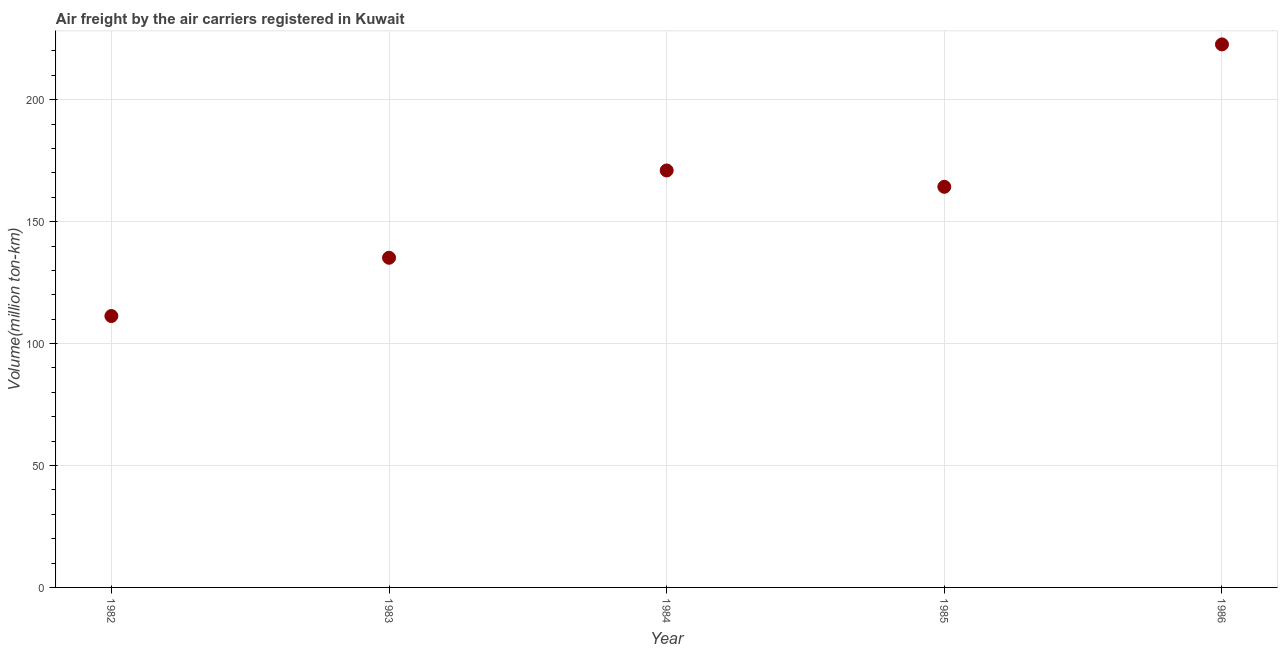What is the air freight in 1983?
Give a very brief answer. 135.2. Across all years, what is the maximum air freight?
Keep it short and to the point. 222.7. Across all years, what is the minimum air freight?
Offer a very short reply. 111.3. In which year was the air freight minimum?
Offer a very short reply. 1982. What is the sum of the air freight?
Ensure brevity in your answer.  804.5. What is the difference between the air freight in 1983 and 1984?
Keep it short and to the point. -35.8. What is the average air freight per year?
Provide a succinct answer. 160.9. What is the median air freight?
Your answer should be very brief. 164.3. What is the ratio of the air freight in 1982 to that in 1983?
Make the answer very short. 0.82. Is the air freight in 1982 less than that in 1986?
Keep it short and to the point. Yes. Is the difference between the air freight in 1984 and 1986 greater than the difference between any two years?
Make the answer very short. No. What is the difference between the highest and the second highest air freight?
Make the answer very short. 51.7. Is the sum of the air freight in 1984 and 1985 greater than the maximum air freight across all years?
Your answer should be compact. Yes. What is the difference between the highest and the lowest air freight?
Your response must be concise. 111.4. Does the air freight monotonically increase over the years?
Your answer should be compact. No. How many years are there in the graph?
Your answer should be compact. 5. What is the difference between two consecutive major ticks on the Y-axis?
Provide a short and direct response. 50. Are the values on the major ticks of Y-axis written in scientific E-notation?
Offer a very short reply. No. What is the title of the graph?
Offer a very short reply. Air freight by the air carriers registered in Kuwait. What is the label or title of the X-axis?
Offer a very short reply. Year. What is the label or title of the Y-axis?
Offer a very short reply. Volume(million ton-km). What is the Volume(million ton-km) in 1982?
Offer a very short reply. 111.3. What is the Volume(million ton-km) in 1983?
Keep it short and to the point. 135.2. What is the Volume(million ton-km) in 1984?
Offer a very short reply. 171. What is the Volume(million ton-km) in 1985?
Offer a terse response. 164.3. What is the Volume(million ton-km) in 1986?
Give a very brief answer. 222.7. What is the difference between the Volume(million ton-km) in 1982 and 1983?
Your response must be concise. -23.9. What is the difference between the Volume(million ton-km) in 1982 and 1984?
Your answer should be compact. -59.7. What is the difference between the Volume(million ton-km) in 1982 and 1985?
Give a very brief answer. -53. What is the difference between the Volume(million ton-km) in 1982 and 1986?
Make the answer very short. -111.4. What is the difference between the Volume(million ton-km) in 1983 and 1984?
Give a very brief answer. -35.8. What is the difference between the Volume(million ton-km) in 1983 and 1985?
Your answer should be compact. -29.1. What is the difference between the Volume(million ton-km) in 1983 and 1986?
Your response must be concise. -87.5. What is the difference between the Volume(million ton-km) in 1984 and 1986?
Your response must be concise. -51.7. What is the difference between the Volume(million ton-km) in 1985 and 1986?
Offer a terse response. -58.4. What is the ratio of the Volume(million ton-km) in 1982 to that in 1983?
Offer a terse response. 0.82. What is the ratio of the Volume(million ton-km) in 1982 to that in 1984?
Provide a short and direct response. 0.65. What is the ratio of the Volume(million ton-km) in 1982 to that in 1985?
Provide a succinct answer. 0.68. What is the ratio of the Volume(million ton-km) in 1982 to that in 1986?
Offer a very short reply. 0.5. What is the ratio of the Volume(million ton-km) in 1983 to that in 1984?
Your answer should be very brief. 0.79. What is the ratio of the Volume(million ton-km) in 1983 to that in 1985?
Ensure brevity in your answer.  0.82. What is the ratio of the Volume(million ton-km) in 1983 to that in 1986?
Your answer should be very brief. 0.61. What is the ratio of the Volume(million ton-km) in 1984 to that in 1985?
Ensure brevity in your answer.  1.04. What is the ratio of the Volume(million ton-km) in 1984 to that in 1986?
Keep it short and to the point. 0.77. What is the ratio of the Volume(million ton-km) in 1985 to that in 1986?
Make the answer very short. 0.74. 